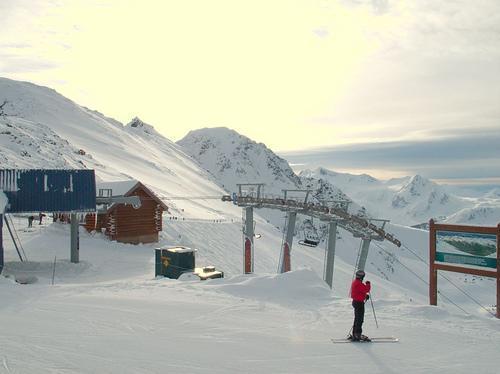How many toilet bowl brushes are in this picture?
Give a very brief answer. 0. 